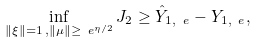Convert formula to latex. <formula><loc_0><loc_0><loc_500><loc_500>\inf _ { \| \xi \| = 1 \, , \| \mu \| \geq \ e ^ { \eta / 2 } } J _ { 2 } \geq \hat { Y } _ { 1 , \ e } - Y _ { 1 , \ e } ,</formula> 